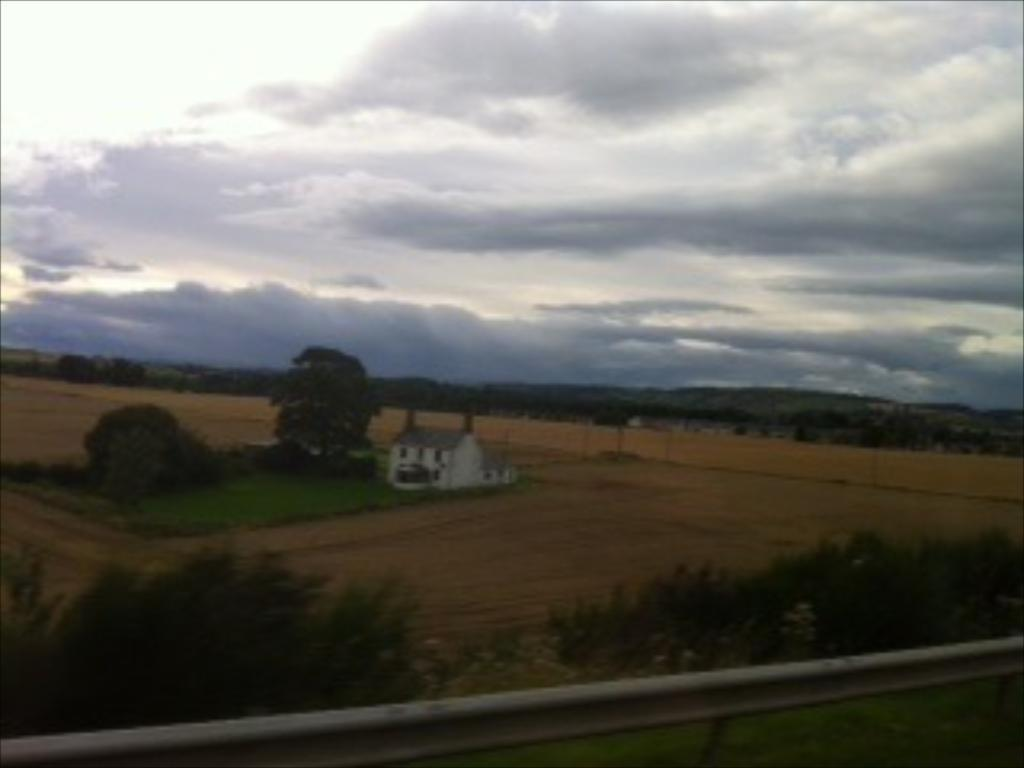What object made of metal can be seen in the image? There is a metal rod in the image. What type of natural vegetation is present in the image? There are trees in the image. What type of structure is visible in the image? There is a house in the image. What can be seen in the sky in the background of the image? There are clouds visible in the background of the image. How many arms are visible on the trees in the image? There are no arms visible on the trees in the image, as trees do not have arms. What type of bedding is present in the image? There is no mention of quilts or any bedding in the image. Is anyone sleeping in the image? There is no indication of anyone sleeping in the image. 